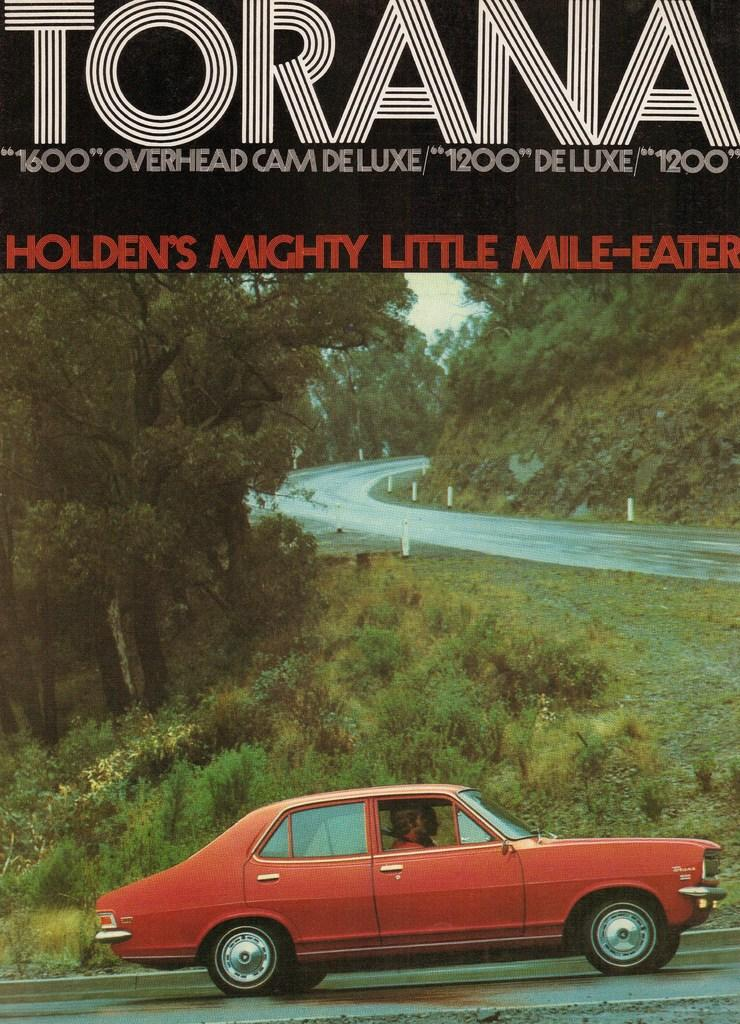What is happening at the bottom of the image? There are persons in a car on the road at the bottom of the image. What can be seen in the background of the image? There are trees, plants, a road, a hill, and the sky visible in the background of the image. What is present at the top of the image? There is text at the top of the image. What type of help is the lawyer providing in the image? There is no lawyer present in the image, so it is not possible to determine what type of help they might be providing. What time of day is it in the image? The provided facts do not mention the time of day, so it cannot be determined from the image. 